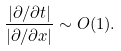<formula> <loc_0><loc_0><loc_500><loc_500>\frac { | \partial / \partial t | } { | \partial / \partial x | } \sim O ( 1 ) .</formula> 